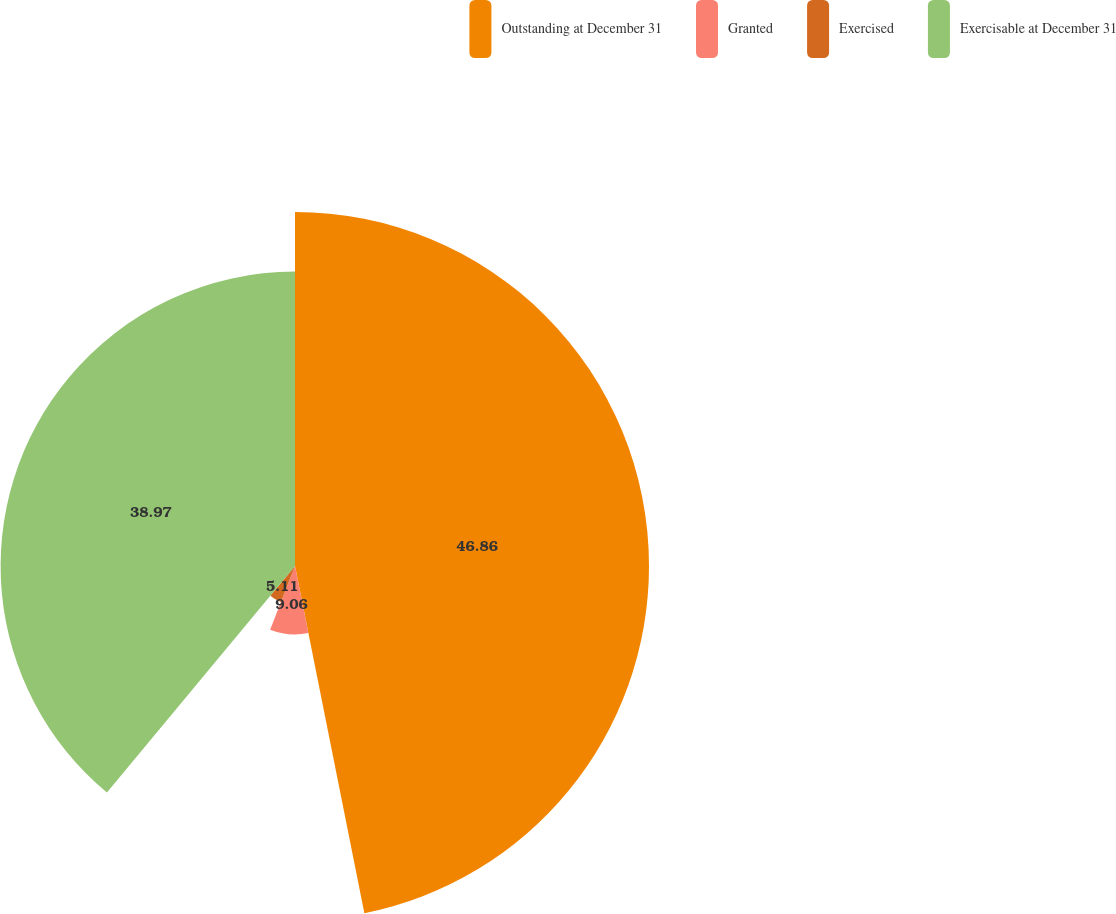<chart> <loc_0><loc_0><loc_500><loc_500><pie_chart><fcel>Outstanding at December 31<fcel>Granted<fcel>Exercised<fcel>Exercisable at December 31<nl><fcel>46.86%<fcel>9.06%<fcel>5.11%<fcel>38.97%<nl></chart> 